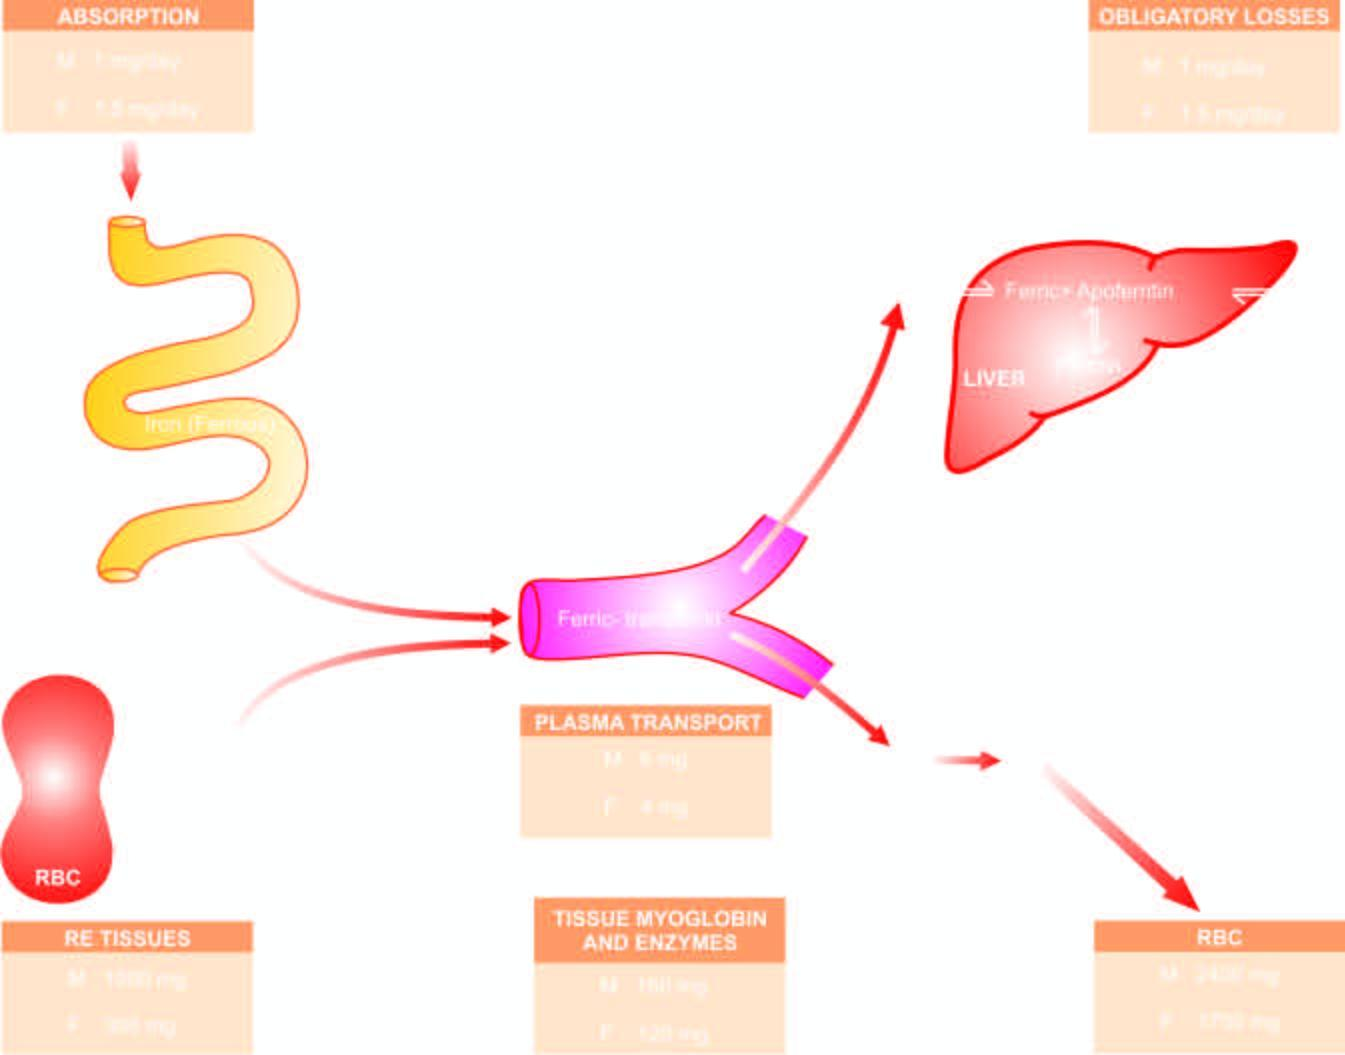s stored iron mobilised in response to increased demand and used for haemoglobin synthesis, thus completing the cycle m = males ; f = females?
Answer the question using a single word or phrase. Yes 